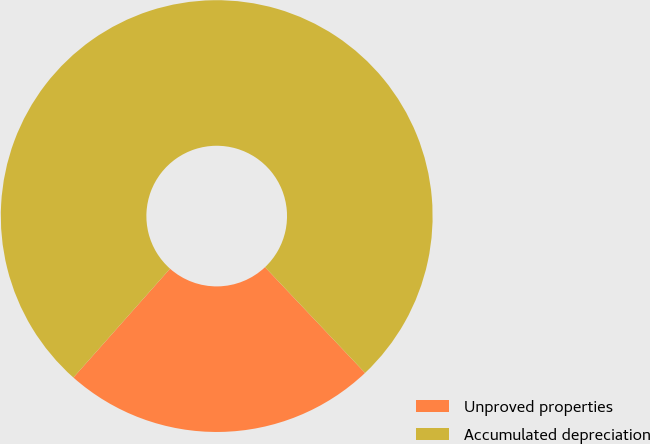Convert chart to OTSL. <chart><loc_0><loc_0><loc_500><loc_500><pie_chart><fcel>Unproved properties<fcel>Accumulated depreciation<nl><fcel>23.61%<fcel>76.39%<nl></chart> 